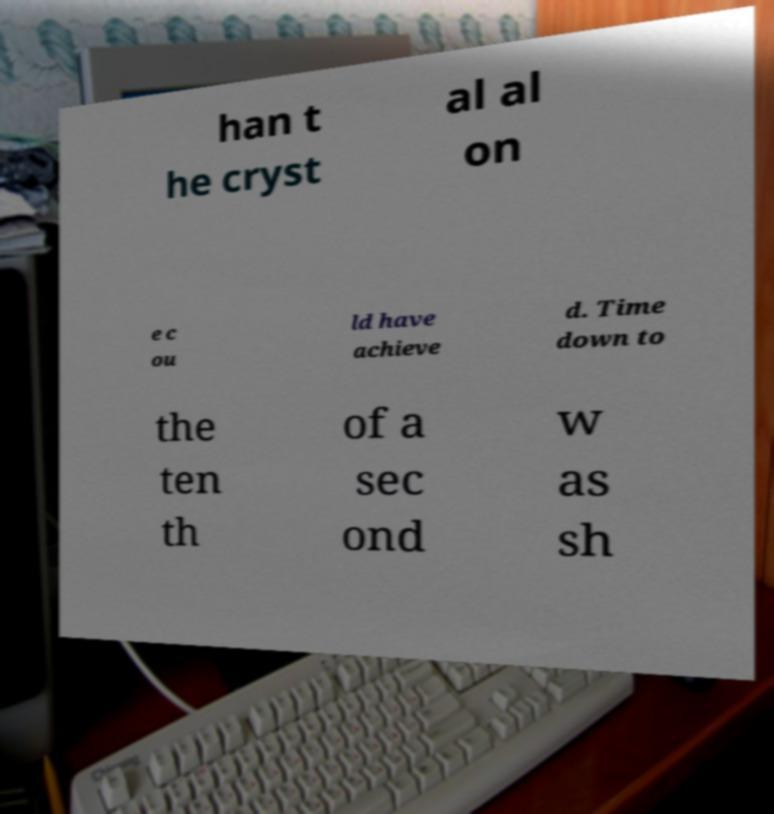Could you assist in decoding the text presented in this image and type it out clearly? han t he cryst al al on e c ou ld have achieve d. Time down to the ten th of a sec ond w as sh 